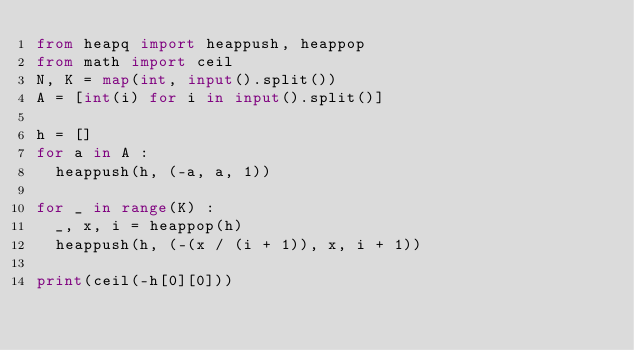<code> <loc_0><loc_0><loc_500><loc_500><_Python_>from heapq import heappush, heappop
from math import ceil
N, K = map(int, input().split())
A = [int(i) for i in input().split()]

h = []
for a in A :
  heappush(h, (-a, a, 1))
  
for _ in range(K) :
  _, x, i = heappop(h)
  heappush(h, (-(x / (i + 1)), x, i + 1))
  
print(ceil(-h[0][0]))</code> 